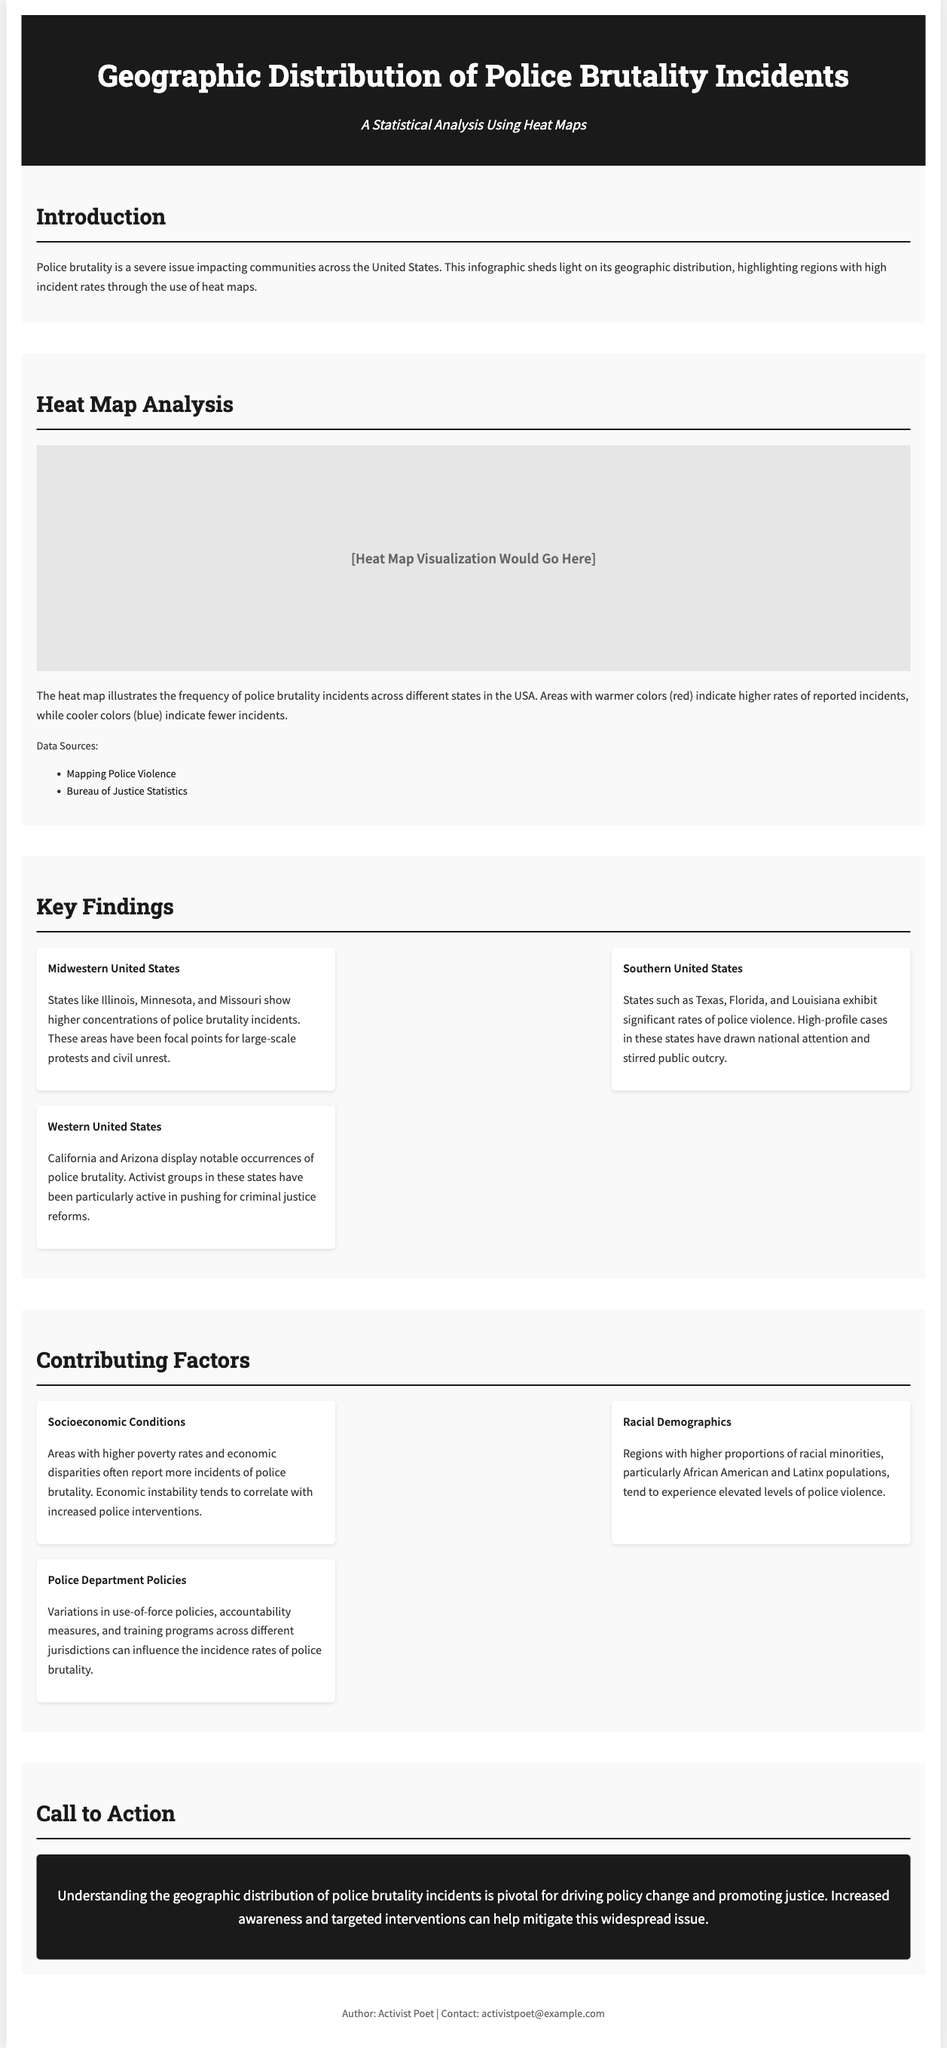What is the primary focus of the infographic? The infographic primarily focuses on the geographic distribution of police brutality incidents across the United States.
Answer: Geographic distribution of police brutality incidents Which regions show higher concentrations of police brutality incidents? The key findings indicate that the Midwestern United States, Southern United States, and Western United States exhibit higher concentrations.
Answer: Midwestern, Southern, and Western United States What are the data sources listed in the document? The data sources listed are Mapping Police Violence and Bureau of Justice Statistics.
Answer: Mapping Police Violence, Bureau of Justice Statistics What color indicates higher rates of police brutality in the heat map? Warmer colors, specifically red, indicate higher rates of reported incidents in the heat map.
Answer: Red What socioeconomic condition is associated with increased police brutality incidents? Areas with higher poverty rates are associated with increased incidents of police brutality.
Answer: Higher poverty rates Which racial demographic is mentioned as experiencing elevated levels of police violence? The document mentions that regions with higher proportions of racial minorities, particularly African American and Latinx populations, experience elevated levels.
Answer: African American and Latinx populations What is one contributing factor to police brutality mentioned? One contributing factor mentioned is police department policies, including variations in use-of-force policies and accountability measures.
Answer: Police department policies What is the document's call to action? The call to action emphasizes the need for understanding the geographic distribution of police brutality incidents to drive policy change and promote justice.
Answer: Understanding for policy change and justice What type of analysis does the infographic primarily utilize? The infographic primarily utilizes heat map analysis to illustrate incident frequencies.
Answer: Heat map analysis 